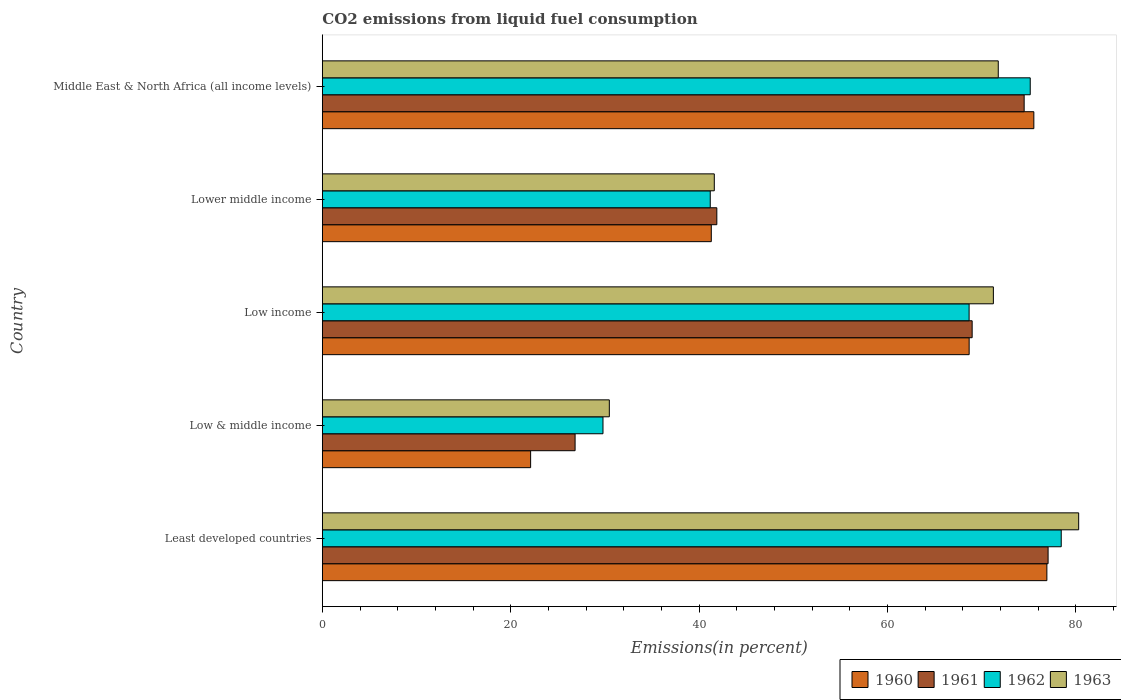Are the number of bars per tick equal to the number of legend labels?
Your answer should be compact. Yes. How many bars are there on the 4th tick from the top?
Make the answer very short. 4. How many bars are there on the 5th tick from the bottom?
Provide a succinct answer. 4. What is the label of the 5th group of bars from the top?
Your answer should be very brief. Least developed countries. What is the total CO2 emitted in 1962 in Low & middle income?
Your response must be concise. 29.8. Across all countries, what is the maximum total CO2 emitted in 1963?
Your answer should be very brief. 80.3. Across all countries, what is the minimum total CO2 emitted in 1962?
Offer a terse response. 29.8. In which country was the total CO2 emitted in 1963 maximum?
Your response must be concise. Least developed countries. In which country was the total CO2 emitted in 1960 minimum?
Your answer should be very brief. Low & middle income. What is the total total CO2 emitted in 1961 in the graph?
Your response must be concise. 289.28. What is the difference between the total CO2 emitted in 1962 in Least developed countries and that in Lower middle income?
Ensure brevity in your answer.  37.26. What is the difference between the total CO2 emitted in 1960 in Least developed countries and the total CO2 emitted in 1962 in Low & middle income?
Offer a very short reply. 47.13. What is the average total CO2 emitted in 1961 per country?
Your response must be concise. 57.86. What is the difference between the total CO2 emitted in 1963 and total CO2 emitted in 1960 in Middle East & North Africa (all income levels)?
Your answer should be very brief. -3.78. In how many countries, is the total CO2 emitted in 1961 greater than 56 %?
Offer a very short reply. 3. What is the ratio of the total CO2 emitted in 1963 in Low & middle income to that in Lower middle income?
Make the answer very short. 0.73. Is the total CO2 emitted in 1962 in Lower middle income less than that in Middle East & North Africa (all income levels)?
Give a very brief answer. Yes. Is the difference between the total CO2 emitted in 1963 in Low income and Lower middle income greater than the difference between the total CO2 emitted in 1960 in Low income and Lower middle income?
Give a very brief answer. Yes. What is the difference between the highest and the second highest total CO2 emitted in 1961?
Your answer should be compact. 2.54. What is the difference between the highest and the lowest total CO2 emitted in 1960?
Offer a very short reply. 54.81. Is it the case that in every country, the sum of the total CO2 emitted in 1960 and total CO2 emitted in 1961 is greater than the sum of total CO2 emitted in 1962 and total CO2 emitted in 1963?
Your answer should be compact. No. What does the 2nd bar from the bottom in Low & middle income represents?
Make the answer very short. 1961. Is it the case that in every country, the sum of the total CO2 emitted in 1960 and total CO2 emitted in 1963 is greater than the total CO2 emitted in 1961?
Your answer should be compact. Yes. Are all the bars in the graph horizontal?
Offer a terse response. Yes. How many countries are there in the graph?
Provide a short and direct response. 5. What is the difference between two consecutive major ticks on the X-axis?
Give a very brief answer. 20. Does the graph contain grids?
Provide a short and direct response. No. Where does the legend appear in the graph?
Make the answer very short. Bottom right. How are the legend labels stacked?
Give a very brief answer. Horizontal. What is the title of the graph?
Ensure brevity in your answer.  CO2 emissions from liquid fuel consumption. Does "2004" appear as one of the legend labels in the graph?
Offer a terse response. No. What is the label or title of the X-axis?
Your response must be concise. Emissions(in percent). What is the Emissions(in percent) in 1960 in Least developed countries?
Keep it short and to the point. 76.93. What is the Emissions(in percent) in 1961 in Least developed countries?
Provide a succinct answer. 77.06. What is the Emissions(in percent) of 1962 in Least developed countries?
Your answer should be compact. 78.45. What is the Emissions(in percent) of 1963 in Least developed countries?
Provide a short and direct response. 80.3. What is the Emissions(in percent) of 1960 in Low & middle income?
Your answer should be very brief. 22.12. What is the Emissions(in percent) of 1961 in Low & middle income?
Offer a terse response. 26.84. What is the Emissions(in percent) of 1962 in Low & middle income?
Make the answer very short. 29.8. What is the Emissions(in percent) in 1963 in Low & middle income?
Give a very brief answer. 30.47. What is the Emissions(in percent) in 1960 in Low income?
Your answer should be very brief. 68.67. What is the Emissions(in percent) of 1961 in Low income?
Ensure brevity in your answer.  68.99. What is the Emissions(in percent) in 1962 in Low income?
Keep it short and to the point. 68.67. What is the Emissions(in percent) of 1963 in Low income?
Your response must be concise. 71.25. What is the Emissions(in percent) in 1960 in Lower middle income?
Give a very brief answer. 41.3. What is the Emissions(in percent) of 1961 in Lower middle income?
Make the answer very short. 41.88. What is the Emissions(in percent) in 1962 in Lower middle income?
Your response must be concise. 41.19. What is the Emissions(in percent) of 1963 in Lower middle income?
Your answer should be very brief. 41.62. What is the Emissions(in percent) in 1960 in Middle East & North Africa (all income levels)?
Make the answer very short. 75.54. What is the Emissions(in percent) of 1961 in Middle East & North Africa (all income levels)?
Offer a terse response. 74.51. What is the Emissions(in percent) in 1962 in Middle East & North Africa (all income levels)?
Offer a very short reply. 75.16. What is the Emissions(in percent) in 1963 in Middle East & North Africa (all income levels)?
Your answer should be very brief. 71.76. Across all countries, what is the maximum Emissions(in percent) in 1960?
Your answer should be compact. 76.93. Across all countries, what is the maximum Emissions(in percent) of 1961?
Make the answer very short. 77.06. Across all countries, what is the maximum Emissions(in percent) in 1962?
Offer a terse response. 78.45. Across all countries, what is the maximum Emissions(in percent) in 1963?
Your answer should be very brief. 80.3. Across all countries, what is the minimum Emissions(in percent) in 1960?
Your answer should be very brief. 22.12. Across all countries, what is the minimum Emissions(in percent) of 1961?
Your answer should be very brief. 26.84. Across all countries, what is the minimum Emissions(in percent) of 1962?
Offer a terse response. 29.8. Across all countries, what is the minimum Emissions(in percent) in 1963?
Make the answer very short. 30.47. What is the total Emissions(in percent) in 1960 in the graph?
Give a very brief answer. 284.55. What is the total Emissions(in percent) in 1961 in the graph?
Give a very brief answer. 289.28. What is the total Emissions(in percent) of 1962 in the graph?
Your answer should be compact. 293.26. What is the total Emissions(in percent) in 1963 in the graph?
Make the answer very short. 295.4. What is the difference between the Emissions(in percent) in 1960 in Least developed countries and that in Low & middle income?
Provide a short and direct response. 54.81. What is the difference between the Emissions(in percent) in 1961 in Least developed countries and that in Low & middle income?
Your answer should be very brief. 50.22. What is the difference between the Emissions(in percent) in 1962 in Least developed countries and that in Low & middle income?
Provide a short and direct response. 48.65. What is the difference between the Emissions(in percent) of 1963 in Least developed countries and that in Low & middle income?
Keep it short and to the point. 49.83. What is the difference between the Emissions(in percent) of 1960 in Least developed countries and that in Low income?
Make the answer very short. 8.25. What is the difference between the Emissions(in percent) in 1961 in Least developed countries and that in Low income?
Make the answer very short. 8.06. What is the difference between the Emissions(in percent) in 1962 in Least developed countries and that in Low income?
Your response must be concise. 9.78. What is the difference between the Emissions(in percent) in 1963 in Least developed countries and that in Low income?
Your answer should be compact. 9.06. What is the difference between the Emissions(in percent) in 1960 in Least developed countries and that in Lower middle income?
Ensure brevity in your answer.  35.63. What is the difference between the Emissions(in percent) of 1961 in Least developed countries and that in Lower middle income?
Provide a short and direct response. 35.17. What is the difference between the Emissions(in percent) in 1962 in Least developed countries and that in Lower middle income?
Provide a short and direct response. 37.26. What is the difference between the Emissions(in percent) in 1963 in Least developed countries and that in Lower middle income?
Your answer should be compact. 38.69. What is the difference between the Emissions(in percent) in 1960 in Least developed countries and that in Middle East & North Africa (all income levels)?
Provide a short and direct response. 1.38. What is the difference between the Emissions(in percent) in 1961 in Least developed countries and that in Middle East & North Africa (all income levels)?
Your response must be concise. 2.54. What is the difference between the Emissions(in percent) in 1962 in Least developed countries and that in Middle East & North Africa (all income levels)?
Provide a succinct answer. 3.29. What is the difference between the Emissions(in percent) in 1963 in Least developed countries and that in Middle East & North Africa (all income levels)?
Your answer should be compact. 8.54. What is the difference between the Emissions(in percent) of 1960 in Low & middle income and that in Low income?
Your answer should be very brief. -46.56. What is the difference between the Emissions(in percent) in 1961 in Low & middle income and that in Low income?
Make the answer very short. -42.16. What is the difference between the Emissions(in percent) of 1962 in Low & middle income and that in Low income?
Ensure brevity in your answer.  -38.87. What is the difference between the Emissions(in percent) of 1963 in Low & middle income and that in Low income?
Ensure brevity in your answer.  -40.77. What is the difference between the Emissions(in percent) of 1960 in Low & middle income and that in Lower middle income?
Offer a terse response. -19.18. What is the difference between the Emissions(in percent) in 1961 in Low & middle income and that in Lower middle income?
Keep it short and to the point. -15.05. What is the difference between the Emissions(in percent) in 1962 in Low & middle income and that in Lower middle income?
Your response must be concise. -11.39. What is the difference between the Emissions(in percent) in 1963 in Low & middle income and that in Lower middle income?
Your answer should be very brief. -11.14. What is the difference between the Emissions(in percent) of 1960 in Low & middle income and that in Middle East & North Africa (all income levels)?
Your answer should be compact. -53.43. What is the difference between the Emissions(in percent) of 1961 in Low & middle income and that in Middle East & North Africa (all income levels)?
Your answer should be very brief. -47.68. What is the difference between the Emissions(in percent) of 1962 in Low & middle income and that in Middle East & North Africa (all income levels)?
Give a very brief answer. -45.36. What is the difference between the Emissions(in percent) in 1963 in Low & middle income and that in Middle East & North Africa (all income levels)?
Offer a terse response. -41.29. What is the difference between the Emissions(in percent) of 1960 in Low income and that in Lower middle income?
Your answer should be compact. 27.38. What is the difference between the Emissions(in percent) in 1961 in Low income and that in Lower middle income?
Give a very brief answer. 27.11. What is the difference between the Emissions(in percent) in 1962 in Low income and that in Lower middle income?
Keep it short and to the point. 27.48. What is the difference between the Emissions(in percent) in 1963 in Low income and that in Lower middle income?
Provide a short and direct response. 29.63. What is the difference between the Emissions(in percent) of 1960 in Low income and that in Middle East & North Africa (all income levels)?
Give a very brief answer. -6.87. What is the difference between the Emissions(in percent) of 1961 in Low income and that in Middle East & North Africa (all income levels)?
Your answer should be compact. -5.52. What is the difference between the Emissions(in percent) of 1962 in Low income and that in Middle East & North Africa (all income levels)?
Your answer should be compact. -6.49. What is the difference between the Emissions(in percent) of 1963 in Low income and that in Middle East & North Africa (all income levels)?
Provide a short and direct response. -0.52. What is the difference between the Emissions(in percent) of 1960 in Lower middle income and that in Middle East & North Africa (all income levels)?
Keep it short and to the point. -34.25. What is the difference between the Emissions(in percent) in 1961 in Lower middle income and that in Middle East & North Africa (all income levels)?
Provide a succinct answer. -32.63. What is the difference between the Emissions(in percent) in 1962 in Lower middle income and that in Middle East & North Africa (all income levels)?
Your answer should be compact. -33.97. What is the difference between the Emissions(in percent) in 1963 in Lower middle income and that in Middle East & North Africa (all income levels)?
Ensure brevity in your answer.  -30.15. What is the difference between the Emissions(in percent) in 1960 in Least developed countries and the Emissions(in percent) in 1961 in Low & middle income?
Your response must be concise. 50.09. What is the difference between the Emissions(in percent) of 1960 in Least developed countries and the Emissions(in percent) of 1962 in Low & middle income?
Offer a very short reply. 47.13. What is the difference between the Emissions(in percent) of 1960 in Least developed countries and the Emissions(in percent) of 1963 in Low & middle income?
Provide a short and direct response. 46.46. What is the difference between the Emissions(in percent) in 1961 in Least developed countries and the Emissions(in percent) in 1962 in Low & middle income?
Make the answer very short. 47.26. What is the difference between the Emissions(in percent) of 1961 in Least developed countries and the Emissions(in percent) of 1963 in Low & middle income?
Your answer should be very brief. 46.58. What is the difference between the Emissions(in percent) in 1962 in Least developed countries and the Emissions(in percent) in 1963 in Low & middle income?
Keep it short and to the point. 47.98. What is the difference between the Emissions(in percent) of 1960 in Least developed countries and the Emissions(in percent) of 1961 in Low income?
Keep it short and to the point. 7.93. What is the difference between the Emissions(in percent) of 1960 in Least developed countries and the Emissions(in percent) of 1962 in Low income?
Offer a very short reply. 8.26. What is the difference between the Emissions(in percent) of 1960 in Least developed countries and the Emissions(in percent) of 1963 in Low income?
Keep it short and to the point. 5.68. What is the difference between the Emissions(in percent) in 1961 in Least developed countries and the Emissions(in percent) in 1962 in Low income?
Ensure brevity in your answer.  8.39. What is the difference between the Emissions(in percent) of 1961 in Least developed countries and the Emissions(in percent) of 1963 in Low income?
Provide a short and direct response. 5.81. What is the difference between the Emissions(in percent) in 1962 in Least developed countries and the Emissions(in percent) in 1963 in Low income?
Make the answer very short. 7.21. What is the difference between the Emissions(in percent) in 1960 in Least developed countries and the Emissions(in percent) in 1961 in Lower middle income?
Ensure brevity in your answer.  35.04. What is the difference between the Emissions(in percent) of 1960 in Least developed countries and the Emissions(in percent) of 1962 in Lower middle income?
Provide a succinct answer. 35.74. What is the difference between the Emissions(in percent) in 1960 in Least developed countries and the Emissions(in percent) in 1963 in Lower middle income?
Offer a terse response. 35.31. What is the difference between the Emissions(in percent) of 1961 in Least developed countries and the Emissions(in percent) of 1962 in Lower middle income?
Your answer should be very brief. 35.87. What is the difference between the Emissions(in percent) of 1961 in Least developed countries and the Emissions(in percent) of 1963 in Lower middle income?
Provide a succinct answer. 35.44. What is the difference between the Emissions(in percent) in 1962 in Least developed countries and the Emissions(in percent) in 1963 in Lower middle income?
Provide a succinct answer. 36.84. What is the difference between the Emissions(in percent) in 1960 in Least developed countries and the Emissions(in percent) in 1961 in Middle East & North Africa (all income levels)?
Keep it short and to the point. 2.41. What is the difference between the Emissions(in percent) in 1960 in Least developed countries and the Emissions(in percent) in 1962 in Middle East & North Africa (all income levels)?
Provide a succinct answer. 1.77. What is the difference between the Emissions(in percent) of 1960 in Least developed countries and the Emissions(in percent) of 1963 in Middle East & North Africa (all income levels)?
Offer a terse response. 5.16. What is the difference between the Emissions(in percent) in 1961 in Least developed countries and the Emissions(in percent) in 1962 in Middle East & North Africa (all income levels)?
Give a very brief answer. 1.9. What is the difference between the Emissions(in percent) of 1961 in Least developed countries and the Emissions(in percent) of 1963 in Middle East & North Africa (all income levels)?
Your answer should be compact. 5.29. What is the difference between the Emissions(in percent) of 1962 in Least developed countries and the Emissions(in percent) of 1963 in Middle East & North Africa (all income levels)?
Ensure brevity in your answer.  6.69. What is the difference between the Emissions(in percent) of 1960 in Low & middle income and the Emissions(in percent) of 1961 in Low income?
Offer a terse response. -46.88. What is the difference between the Emissions(in percent) of 1960 in Low & middle income and the Emissions(in percent) of 1962 in Low income?
Make the answer very short. -46.56. What is the difference between the Emissions(in percent) in 1960 in Low & middle income and the Emissions(in percent) in 1963 in Low income?
Your response must be concise. -49.13. What is the difference between the Emissions(in percent) in 1961 in Low & middle income and the Emissions(in percent) in 1962 in Low income?
Ensure brevity in your answer.  -41.83. What is the difference between the Emissions(in percent) of 1961 in Low & middle income and the Emissions(in percent) of 1963 in Low income?
Provide a succinct answer. -44.41. What is the difference between the Emissions(in percent) in 1962 in Low & middle income and the Emissions(in percent) in 1963 in Low income?
Keep it short and to the point. -41.45. What is the difference between the Emissions(in percent) in 1960 in Low & middle income and the Emissions(in percent) in 1961 in Lower middle income?
Offer a terse response. -19.77. What is the difference between the Emissions(in percent) in 1960 in Low & middle income and the Emissions(in percent) in 1962 in Lower middle income?
Provide a succinct answer. -19.07. What is the difference between the Emissions(in percent) of 1960 in Low & middle income and the Emissions(in percent) of 1963 in Lower middle income?
Provide a short and direct response. -19.5. What is the difference between the Emissions(in percent) in 1961 in Low & middle income and the Emissions(in percent) in 1962 in Lower middle income?
Make the answer very short. -14.35. What is the difference between the Emissions(in percent) of 1961 in Low & middle income and the Emissions(in percent) of 1963 in Lower middle income?
Offer a very short reply. -14.78. What is the difference between the Emissions(in percent) of 1962 in Low & middle income and the Emissions(in percent) of 1963 in Lower middle income?
Your answer should be very brief. -11.82. What is the difference between the Emissions(in percent) in 1960 in Low & middle income and the Emissions(in percent) in 1961 in Middle East & North Africa (all income levels)?
Keep it short and to the point. -52.4. What is the difference between the Emissions(in percent) of 1960 in Low & middle income and the Emissions(in percent) of 1962 in Middle East & North Africa (all income levels)?
Make the answer very short. -53.04. What is the difference between the Emissions(in percent) of 1960 in Low & middle income and the Emissions(in percent) of 1963 in Middle East & North Africa (all income levels)?
Provide a succinct answer. -49.65. What is the difference between the Emissions(in percent) of 1961 in Low & middle income and the Emissions(in percent) of 1962 in Middle East & North Africa (all income levels)?
Provide a succinct answer. -48.32. What is the difference between the Emissions(in percent) of 1961 in Low & middle income and the Emissions(in percent) of 1963 in Middle East & North Africa (all income levels)?
Give a very brief answer. -44.93. What is the difference between the Emissions(in percent) of 1962 in Low & middle income and the Emissions(in percent) of 1963 in Middle East & North Africa (all income levels)?
Your answer should be compact. -41.97. What is the difference between the Emissions(in percent) in 1960 in Low income and the Emissions(in percent) in 1961 in Lower middle income?
Your answer should be compact. 26.79. What is the difference between the Emissions(in percent) in 1960 in Low income and the Emissions(in percent) in 1962 in Lower middle income?
Offer a terse response. 27.49. What is the difference between the Emissions(in percent) of 1960 in Low income and the Emissions(in percent) of 1963 in Lower middle income?
Give a very brief answer. 27.06. What is the difference between the Emissions(in percent) in 1961 in Low income and the Emissions(in percent) in 1962 in Lower middle income?
Your answer should be very brief. 27.81. What is the difference between the Emissions(in percent) of 1961 in Low income and the Emissions(in percent) of 1963 in Lower middle income?
Ensure brevity in your answer.  27.38. What is the difference between the Emissions(in percent) of 1962 in Low income and the Emissions(in percent) of 1963 in Lower middle income?
Give a very brief answer. 27.05. What is the difference between the Emissions(in percent) in 1960 in Low income and the Emissions(in percent) in 1961 in Middle East & North Africa (all income levels)?
Your answer should be compact. -5.84. What is the difference between the Emissions(in percent) of 1960 in Low income and the Emissions(in percent) of 1962 in Middle East & North Africa (all income levels)?
Keep it short and to the point. -6.49. What is the difference between the Emissions(in percent) in 1960 in Low income and the Emissions(in percent) in 1963 in Middle East & North Africa (all income levels)?
Provide a short and direct response. -3.09. What is the difference between the Emissions(in percent) in 1961 in Low income and the Emissions(in percent) in 1962 in Middle East & North Africa (all income levels)?
Keep it short and to the point. -6.17. What is the difference between the Emissions(in percent) in 1961 in Low income and the Emissions(in percent) in 1963 in Middle East & North Africa (all income levels)?
Give a very brief answer. -2.77. What is the difference between the Emissions(in percent) in 1962 in Low income and the Emissions(in percent) in 1963 in Middle East & North Africa (all income levels)?
Ensure brevity in your answer.  -3.09. What is the difference between the Emissions(in percent) in 1960 in Lower middle income and the Emissions(in percent) in 1961 in Middle East & North Africa (all income levels)?
Provide a succinct answer. -33.22. What is the difference between the Emissions(in percent) of 1960 in Lower middle income and the Emissions(in percent) of 1962 in Middle East & North Africa (all income levels)?
Give a very brief answer. -33.86. What is the difference between the Emissions(in percent) of 1960 in Lower middle income and the Emissions(in percent) of 1963 in Middle East & North Africa (all income levels)?
Offer a very short reply. -30.47. What is the difference between the Emissions(in percent) of 1961 in Lower middle income and the Emissions(in percent) of 1962 in Middle East & North Africa (all income levels)?
Keep it short and to the point. -33.28. What is the difference between the Emissions(in percent) of 1961 in Lower middle income and the Emissions(in percent) of 1963 in Middle East & North Africa (all income levels)?
Your answer should be very brief. -29.88. What is the difference between the Emissions(in percent) of 1962 in Lower middle income and the Emissions(in percent) of 1963 in Middle East & North Africa (all income levels)?
Keep it short and to the point. -30.58. What is the average Emissions(in percent) in 1960 per country?
Your response must be concise. 56.91. What is the average Emissions(in percent) of 1961 per country?
Ensure brevity in your answer.  57.86. What is the average Emissions(in percent) in 1962 per country?
Provide a succinct answer. 58.65. What is the average Emissions(in percent) in 1963 per country?
Make the answer very short. 59.08. What is the difference between the Emissions(in percent) in 1960 and Emissions(in percent) in 1961 in Least developed countries?
Provide a short and direct response. -0.13. What is the difference between the Emissions(in percent) of 1960 and Emissions(in percent) of 1962 in Least developed countries?
Your answer should be very brief. -1.52. What is the difference between the Emissions(in percent) in 1960 and Emissions(in percent) in 1963 in Least developed countries?
Provide a short and direct response. -3.38. What is the difference between the Emissions(in percent) of 1961 and Emissions(in percent) of 1962 in Least developed countries?
Your answer should be very brief. -1.4. What is the difference between the Emissions(in percent) in 1961 and Emissions(in percent) in 1963 in Least developed countries?
Provide a succinct answer. -3.25. What is the difference between the Emissions(in percent) in 1962 and Emissions(in percent) in 1963 in Least developed countries?
Ensure brevity in your answer.  -1.85. What is the difference between the Emissions(in percent) in 1960 and Emissions(in percent) in 1961 in Low & middle income?
Offer a terse response. -4.72. What is the difference between the Emissions(in percent) in 1960 and Emissions(in percent) in 1962 in Low & middle income?
Give a very brief answer. -7.68. What is the difference between the Emissions(in percent) of 1960 and Emissions(in percent) of 1963 in Low & middle income?
Offer a terse response. -8.36. What is the difference between the Emissions(in percent) of 1961 and Emissions(in percent) of 1962 in Low & middle income?
Provide a succinct answer. -2.96. What is the difference between the Emissions(in percent) of 1961 and Emissions(in percent) of 1963 in Low & middle income?
Your answer should be compact. -3.63. What is the difference between the Emissions(in percent) in 1962 and Emissions(in percent) in 1963 in Low & middle income?
Keep it short and to the point. -0.67. What is the difference between the Emissions(in percent) in 1960 and Emissions(in percent) in 1961 in Low income?
Provide a succinct answer. -0.32. What is the difference between the Emissions(in percent) in 1960 and Emissions(in percent) in 1962 in Low income?
Provide a succinct answer. 0. What is the difference between the Emissions(in percent) in 1960 and Emissions(in percent) in 1963 in Low income?
Provide a succinct answer. -2.57. What is the difference between the Emissions(in percent) in 1961 and Emissions(in percent) in 1962 in Low income?
Your response must be concise. 0.32. What is the difference between the Emissions(in percent) in 1961 and Emissions(in percent) in 1963 in Low income?
Provide a succinct answer. -2.25. What is the difference between the Emissions(in percent) of 1962 and Emissions(in percent) of 1963 in Low income?
Your response must be concise. -2.58. What is the difference between the Emissions(in percent) of 1960 and Emissions(in percent) of 1961 in Lower middle income?
Give a very brief answer. -0.59. What is the difference between the Emissions(in percent) of 1960 and Emissions(in percent) of 1962 in Lower middle income?
Your answer should be very brief. 0.11. What is the difference between the Emissions(in percent) of 1960 and Emissions(in percent) of 1963 in Lower middle income?
Make the answer very short. -0.32. What is the difference between the Emissions(in percent) in 1961 and Emissions(in percent) in 1962 in Lower middle income?
Your answer should be compact. 0.7. What is the difference between the Emissions(in percent) in 1961 and Emissions(in percent) in 1963 in Lower middle income?
Your answer should be very brief. 0.27. What is the difference between the Emissions(in percent) of 1962 and Emissions(in percent) of 1963 in Lower middle income?
Provide a succinct answer. -0.43. What is the difference between the Emissions(in percent) in 1960 and Emissions(in percent) in 1961 in Middle East & North Africa (all income levels)?
Offer a terse response. 1.03. What is the difference between the Emissions(in percent) in 1960 and Emissions(in percent) in 1962 in Middle East & North Africa (all income levels)?
Provide a short and direct response. 0.38. What is the difference between the Emissions(in percent) of 1960 and Emissions(in percent) of 1963 in Middle East & North Africa (all income levels)?
Provide a succinct answer. 3.78. What is the difference between the Emissions(in percent) of 1961 and Emissions(in percent) of 1962 in Middle East & North Africa (all income levels)?
Make the answer very short. -0.65. What is the difference between the Emissions(in percent) in 1961 and Emissions(in percent) in 1963 in Middle East & North Africa (all income levels)?
Your response must be concise. 2.75. What is the difference between the Emissions(in percent) of 1962 and Emissions(in percent) of 1963 in Middle East & North Africa (all income levels)?
Offer a very short reply. 3.4. What is the ratio of the Emissions(in percent) of 1960 in Least developed countries to that in Low & middle income?
Keep it short and to the point. 3.48. What is the ratio of the Emissions(in percent) of 1961 in Least developed countries to that in Low & middle income?
Your answer should be compact. 2.87. What is the ratio of the Emissions(in percent) in 1962 in Least developed countries to that in Low & middle income?
Your answer should be very brief. 2.63. What is the ratio of the Emissions(in percent) in 1963 in Least developed countries to that in Low & middle income?
Your response must be concise. 2.64. What is the ratio of the Emissions(in percent) in 1960 in Least developed countries to that in Low income?
Provide a short and direct response. 1.12. What is the ratio of the Emissions(in percent) in 1961 in Least developed countries to that in Low income?
Ensure brevity in your answer.  1.12. What is the ratio of the Emissions(in percent) of 1962 in Least developed countries to that in Low income?
Give a very brief answer. 1.14. What is the ratio of the Emissions(in percent) of 1963 in Least developed countries to that in Low income?
Offer a terse response. 1.13. What is the ratio of the Emissions(in percent) in 1960 in Least developed countries to that in Lower middle income?
Give a very brief answer. 1.86. What is the ratio of the Emissions(in percent) of 1961 in Least developed countries to that in Lower middle income?
Provide a short and direct response. 1.84. What is the ratio of the Emissions(in percent) in 1962 in Least developed countries to that in Lower middle income?
Your response must be concise. 1.9. What is the ratio of the Emissions(in percent) in 1963 in Least developed countries to that in Lower middle income?
Ensure brevity in your answer.  1.93. What is the ratio of the Emissions(in percent) in 1960 in Least developed countries to that in Middle East & North Africa (all income levels)?
Offer a very short reply. 1.02. What is the ratio of the Emissions(in percent) in 1961 in Least developed countries to that in Middle East & North Africa (all income levels)?
Provide a short and direct response. 1.03. What is the ratio of the Emissions(in percent) in 1962 in Least developed countries to that in Middle East & North Africa (all income levels)?
Keep it short and to the point. 1.04. What is the ratio of the Emissions(in percent) of 1963 in Least developed countries to that in Middle East & North Africa (all income levels)?
Ensure brevity in your answer.  1.12. What is the ratio of the Emissions(in percent) in 1960 in Low & middle income to that in Low income?
Make the answer very short. 0.32. What is the ratio of the Emissions(in percent) in 1961 in Low & middle income to that in Low income?
Make the answer very short. 0.39. What is the ratio of the Emissions(in percent) in 1962 in Low & middle income to that in Low income?
Your response must be concise. 0.43. What is the ratio of the Emissions(in percent) in 1963 in Low & middle income to that in Low income?
Ensure brevity in your answer.  0.43. What is the ratio of the Emissions(in percent) of 1960 in Low & middle income to that in Lower middle income?
Ensure brevity in your answer.  0.54. What is the ratio of the Emissions(in percent) of 1961 in Low & middle income to that in Lower middle income?
Ensure brevity in your answer.  0.64. What is the ratio of the Emissions(in percent) of 1962 in Low & middle income to that in Lower middle income?
Offer a terse response. 0.72. What is the ratio of the Emissions(in percent) of 1963 in Low & middle income to that in Lower middle income?
Provide a short and direct response. 0.73. What is the ratio of the Emissions(in percent) of 1960 in Low & middle income to that in Middle East & North Africa (all income levels)?
Your answer should be very brief. 0.29. What is the ratio of the Emissions(in percent) of 1961 in Low & middle income to that in Middle East & North Africa (all income levels)?
Provide a short and direct response. 0.36. What is the ratio of the Emissions(in percent) in 1962 in Low & middle income to that in Middle East & North Africa (all income levels)?
Offer a very short reply. 0.4. What is the ratio of the Emissions(in percent) in 1963 in Low & middle income to that in Middle East & North Africa (all income levels)?
Make the answer very short. 0.42. What is the ratio of the Emissions(in percent) of 1960 in Low income to that in Lower middle income?
Your answer should be very brief. 1.66. What is the ratio of the Emissions(in percent) in 1961 in Low income to that in Lower middle income?
Keep it short and to the point. 1.65. What is the ratio of the Emissions(in percent) in 1962 in Low income to that in Lower middle income?
Give a very brief answer. 1.67. What is the ratio of the Emissions(in percent) in 1963 in Low income to that in Lower middle income?
Provide a succinct answer. 1.71. What is the ratio of the Emissions(in percent) in 1960 in Low income to that in Middle East & North Africa (all income levels)?
Provide a succinct answer. 0.91. What is the ratio of the Emissions(in percent) of 1961 in Low income to that in Middle East & North Africa (all income levels)?
Offer a very short reply. 0.93. What is the ratio of the Emissions(in percent) in 1962 in Low income to that in Middle East & North Africa (all income levels)?
Your response must be concise. 0.91. What is the ratio of the Emissions(in percent) in 1963 in Low income to that in Middle East & North Africa (all income levels)?
Offer a terse response. 0.99. What is the ratio of the Emissions(in percent) in 1960 in Lower middle income to that in Middle East & North Africa (all income levels)?
Provide a short and direct response. 0.55. What is the ratio of the Emissions(in percent) of 1961 in Lower middle income to that in Middle East & North Africa (all income levels)?
Provide a succinct answer. 0.56. What is the ratio of the Emissions(in percent) of 1962 in Lower middle income to that in Middle East & North Africa (all income levels)?
Keep it short and to the point. 0.55. What is the ratio of the Emissions(in percent) of 1963 in Lower middle income to that in Middle East & North Africa (all income levels)?
Ensure brevity in your answer.  0.58. What is the difference between the highest and the second highest Emissions(in percent) of 1960?
Give a very brief answer. 1.38. What is the difference between the highest and the second highest Emissions(in percent) in 1961?
Offer a terse response. 2.54. What is the difference between the highest and the second highest Emissions(in percent) in 1962?
Make the answer very short. 3.29. What is the difference between the highest and the second highest Emissions(in percent) in 1963?
Keep it short and to the point. 8.54. What is the difference between the highest and the lowest Emissions(in percent) in 1960?
Offer a very short reply. 54.81. What is the difference between the highest and the lowest Emissions(in percent) in 1961?
Provide a short and direct response. 50.22. What is the difference between the highest and the lowest Emissions(in percent) in 1962?
Offer a terse response. 48.65. What is the difference between the highest and the lowest Emissions(in percent) in 1963?
Offer a terse response. 49.83. 